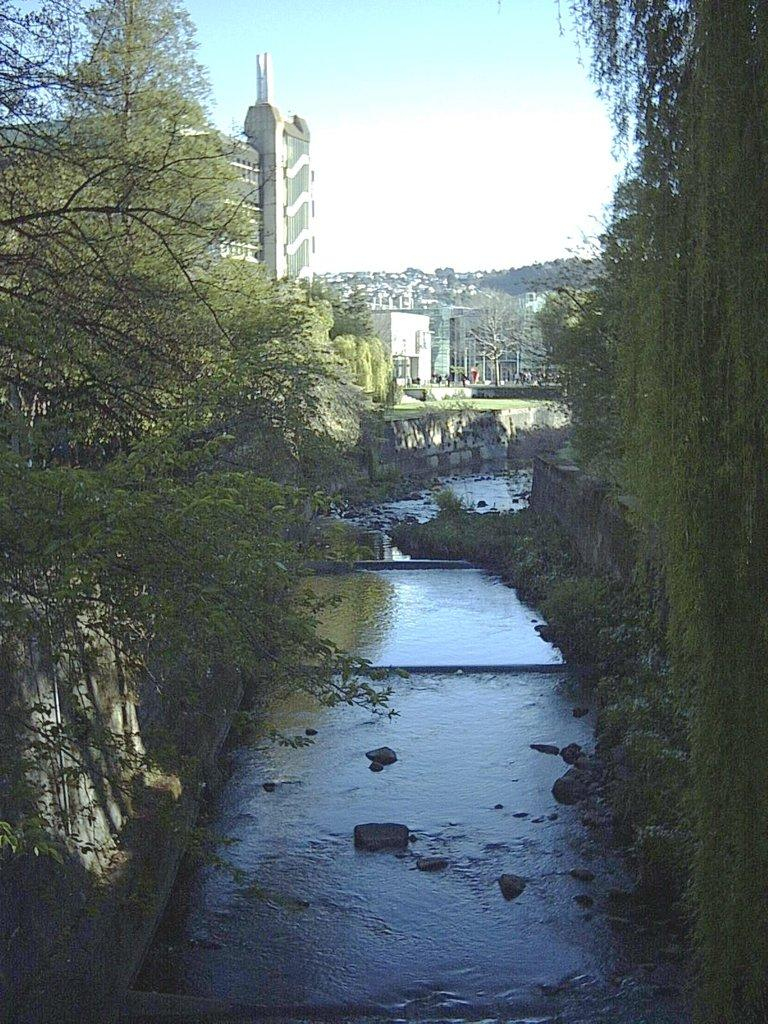What is the main feature in the center of the image? There is a canal in the center of the image. What can be seen on the left side of the image? There is a tree on the left side of the image. What is visible in the background of the image? There are buildings, hills, and the sky visible in the background of the image. What type of writing can be seen on the tree in the image? There is no writing visible on the tree in the image. How does the fear of heights affect the hills in the image? There is no fear of heights mentioned in the image, and the hills are not affected by any emotions. 